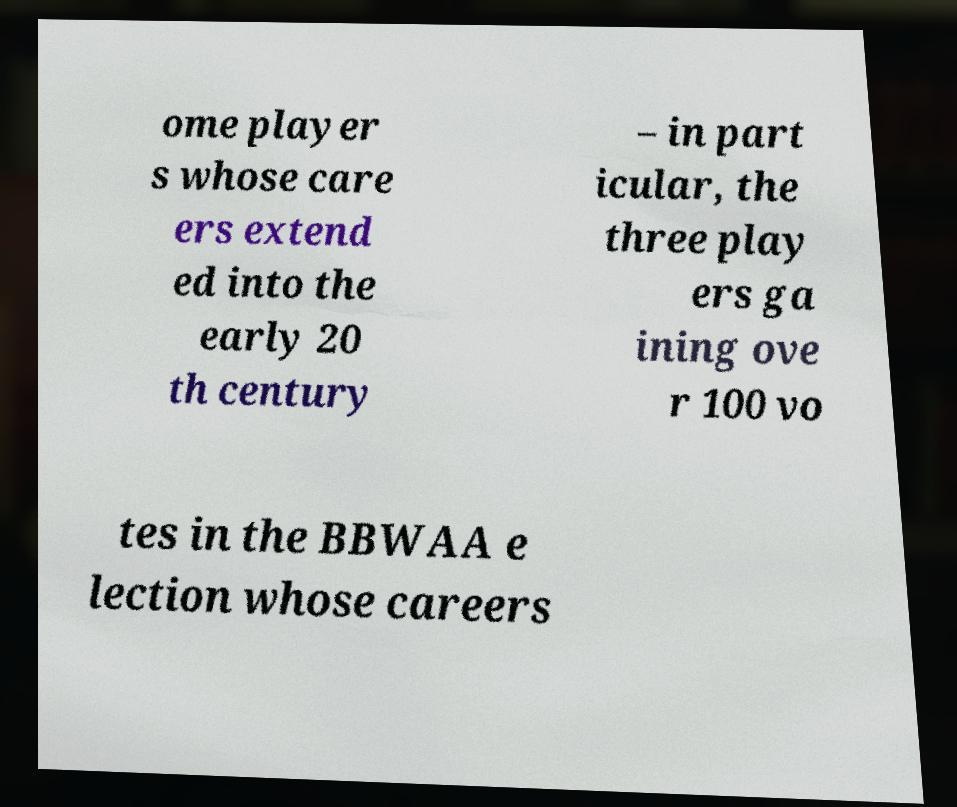Could you assist in decoding the text presented in this image and type it out clearly? ome player s whose care ers extend ed into the early 20 th century – in part icular, the three play ers ga ining ove r 100 vo tes in the BBWAA e lection whose careers 